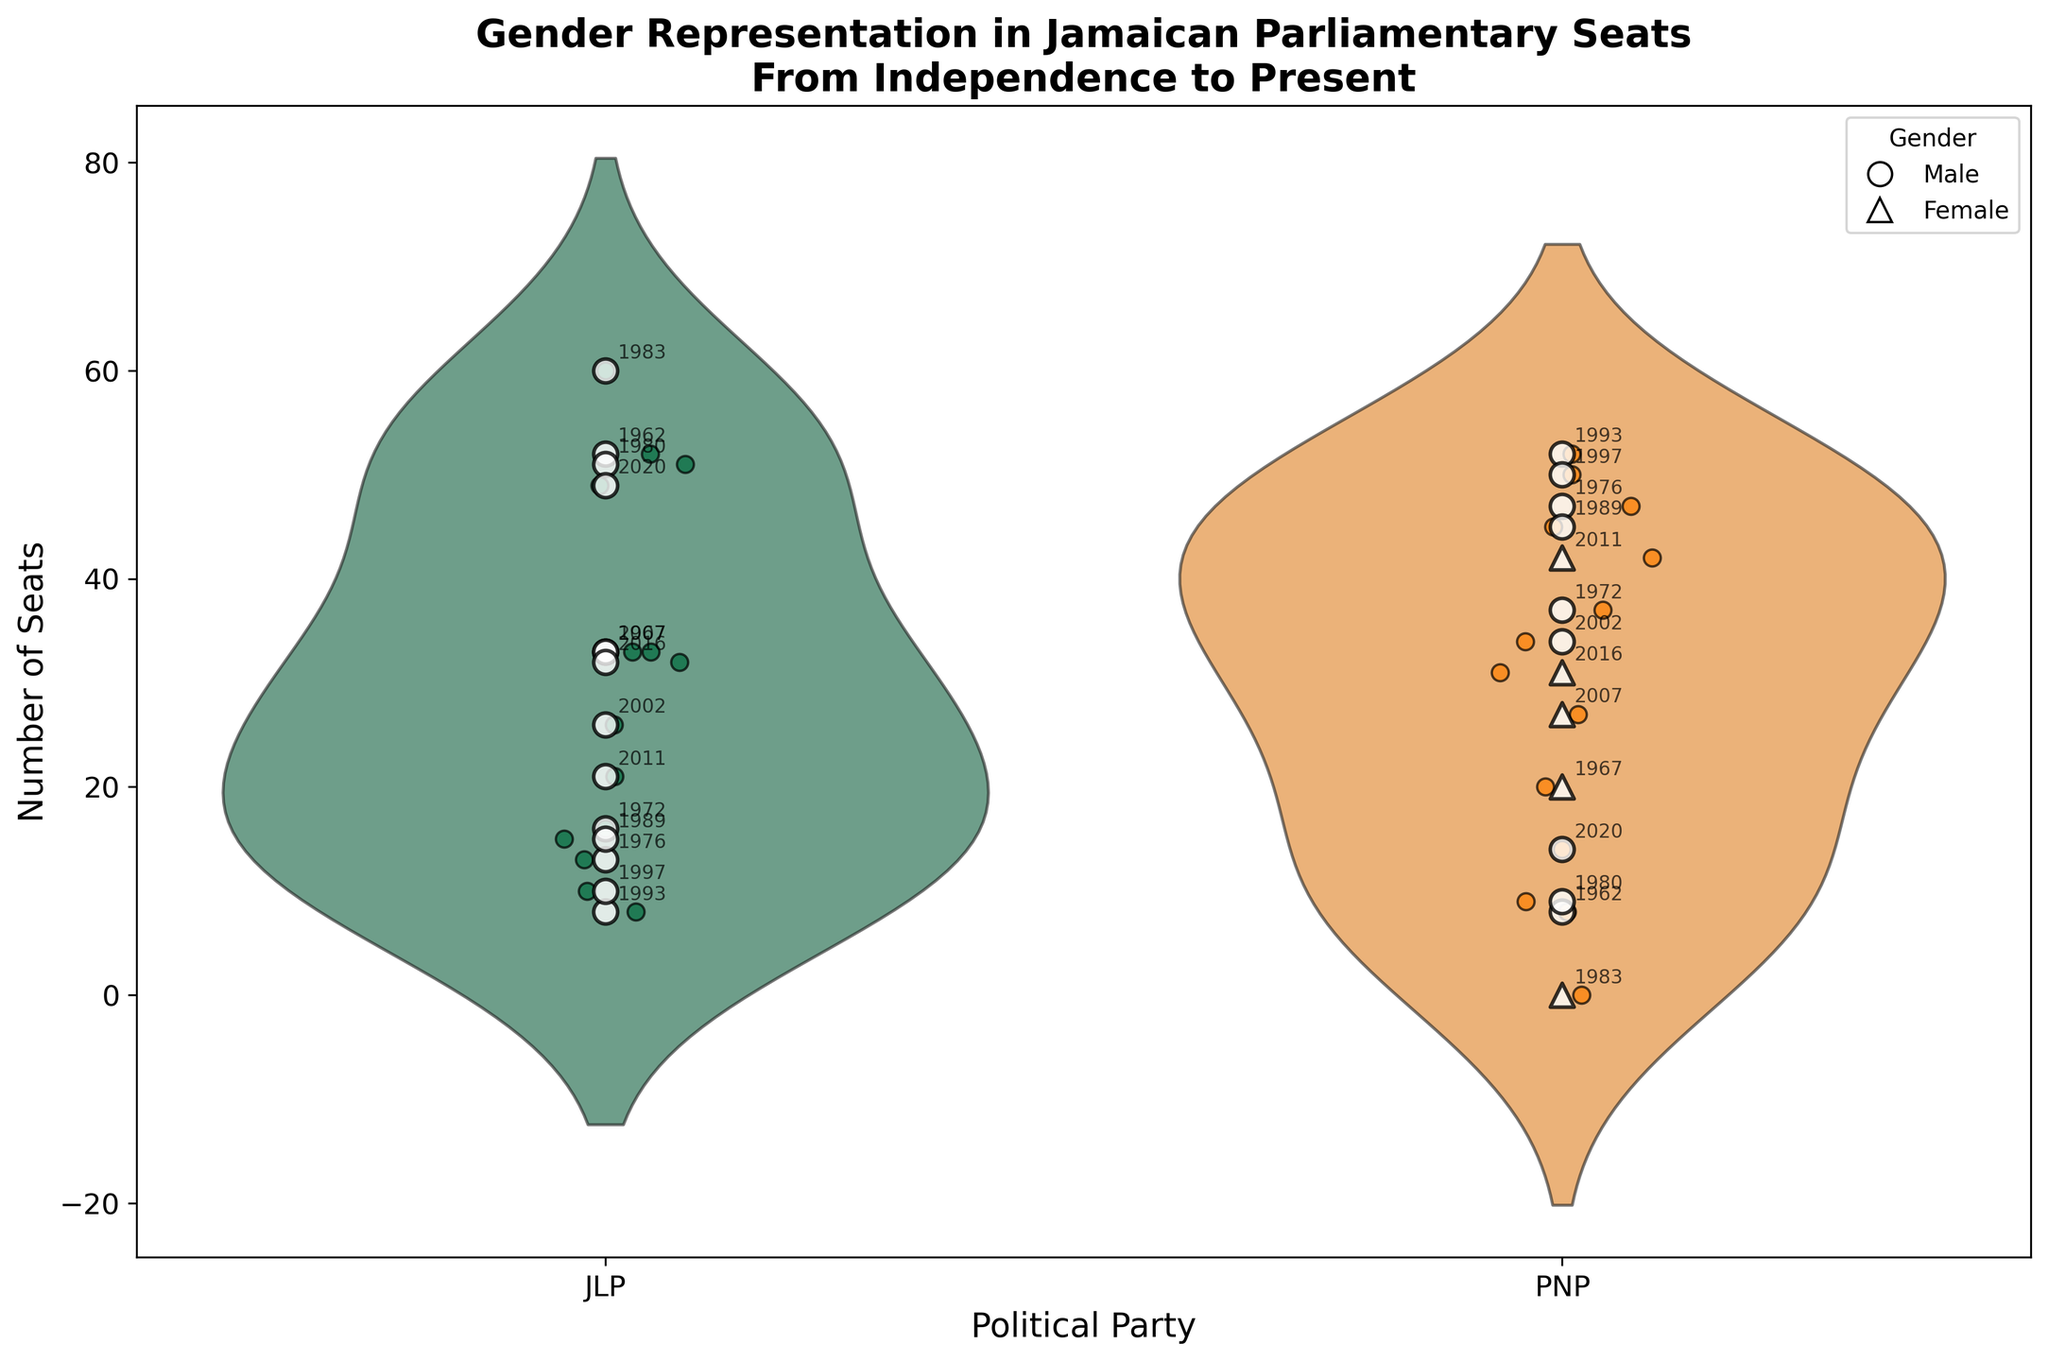What is the title of the figure? The title is usually located at the top of the figure and provides a summary of what the figure is about. In this case, it reads "Gender Representation in Jamaican Parliamentary Seats From Independence to Present".
Answer: Gender Representation in Jamaican Parliamentary Seats From Independence to Present How many parties are represented in the figure? The x-axis lists the political parties being compared. There are two categories, labeled as JLP (Jamaica Labour Party) and PNP (People's National Party).
Answer: 2 What shape represents male gender in the figure? The figure uses white circle markers (o) with black edges to indicate male representatives. This information is also reinforced in the legend in the upper right corner.
Answer: Circle (o) What is the highest number of seats won by the JLP in a single election? To find the maximum value on the y-axis for the JLP category, we observe the highest point on the violin plot and jittered points corresponding to the JLP. It's at the 60 seats line, which occurred in the 1983 election.
Answer: 60 Who held the most seats in the 2016 election and which party did they belong to? By noting the year annotations and seats marked within the JLP and PNP categories for 2016, we can see the JLP held 32 seats while the PNP held 31 seats. Andrew Holness (JLP) had the most seats.
Answer: Andrew Holness, JLP Which party generally has a wider distribution of seats over the examined period? The width of each violin plot indicates the distribution of seats. The JLP's violin plot is wider, indicating a more varied distribution compared to the PNP's narrower plot.
Answer: JLP How many female leaders can be identified in the plot and which parties did they represent? Observe the triangle markers (^) within the two party categories. There are two female leaders, both triangles are in the PNP category, representing Nora Schirilla, Cynthia Burrell, and Portia Simpson-Miller.
Answer: 3, PNP Compare the median number of seats held by the JLP and PNP. Which party had a higher median? The median can be estimated by finding the central tendency in the violin plots. The horizontal thickness at the waist of the violin plot for each party indicates the median. The JLP seems to have a higher median seat count than the PNP.
Answer: JLP Which election year shows the largest disparity in seats between the two parties? By comparing the pairs of seat counts for each election year, the largest difference appears in the 1980 election where JLP held 51 seats and PNP held 9 seats. The disparity is 42 seats.
Answer: 1980 In which election did a single party win all 60 seats? The spike at 60 seats in the violin plot and a horizontal line above it indicate a year where all seats were won by one party. In the annotations, it's indicated in the 1983 election where the JLP won all 60 seats.
Answer: 1983 